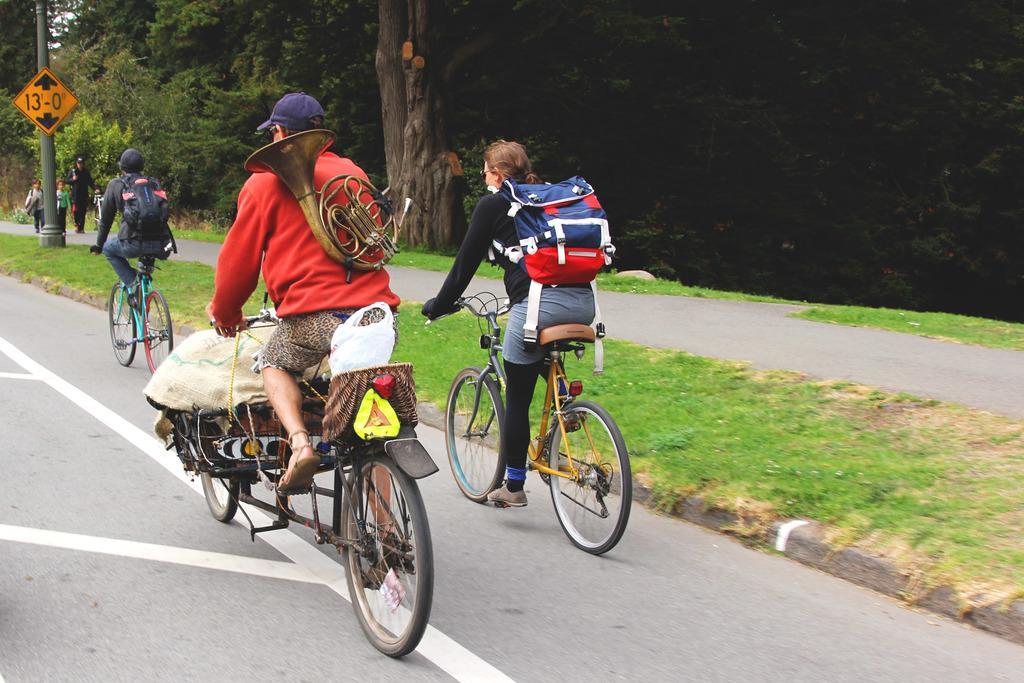Please provide a concise description of this image. In this image there is a person riding bicycle by carrying a french horns , and a woman riding a bicycle , another person riding a bicycle , and at back ground there is a tree , walkway , grass , group of people walking , a sign board attached to the pole. 